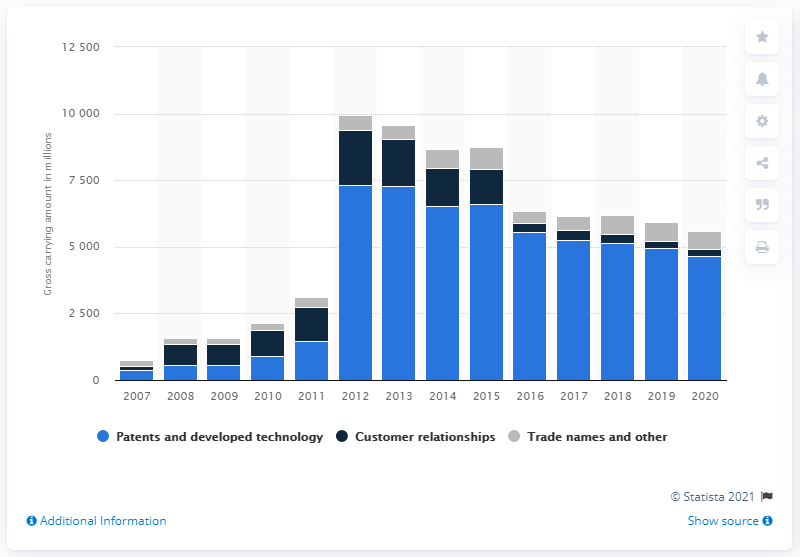Draw attention to some important aspects in this diagram. The gross carrying amount of Alphabet's intangible patents and technology assets was $4,639. 